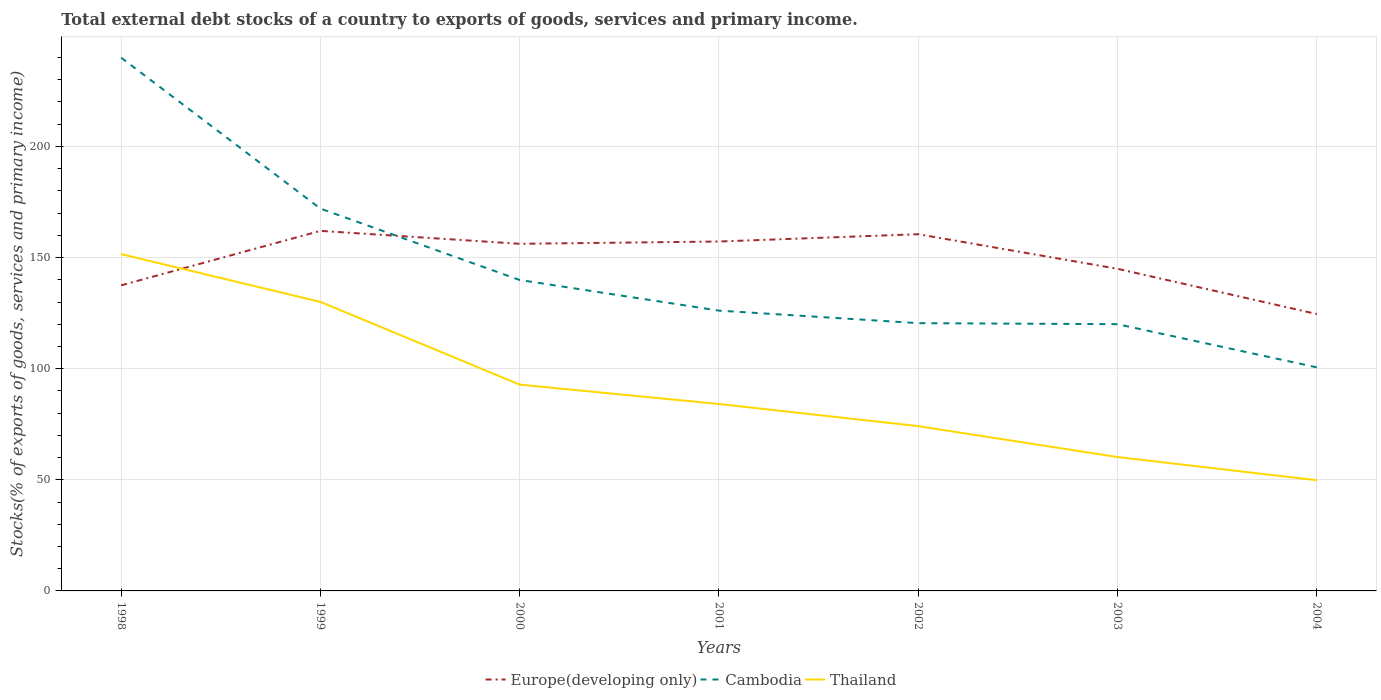How many different coloured lines are there?
Give a very brief answer. 3. Does the line corresponding to Europe(developing only) intersect with the line corresponding to Cambodia?
Offer a very short reply. Yes. Is the number of lines equal to the number of legend labels?
Offer a terse response. Yes. Across all years, what is the maximum total debt stocks in Thailand?
Offer a very short reply. 49.81. In which year was the total debt stocks in Thailand maximum?
Your answer should be compact. 2004. What is the total total debt stocks in Thailand in the graph?
Offer a very short reply. 10.43. What is the difference between the highest and the second highest total debt stocks in Europe(developing only)?
Keep it short and to the point. 37.42. What is the difference between the highest and the lowest total debt stocks in Europe(developing only)?
Your answer should be very brief. 4. Is the total debt stocks in Cambodia strictly greater than the total debt stocks in Europe(developing only) over the years?
Your response must be concise. No. How many lines are there?
Your answer should be compact. 3. How many years are there in the graph?
Your answer should be compact. 7. What is the difference between two consecutive major ticks on the Y-axis?
Provide a short and direct response. 50. Where does the legend appear in the graph?
Your answer should be very brief. Bottom center. What is the title of the graph?
Ensure brevity in your answer.  Total external debt stocks of a country to exports of goods, services and primary income. Does "Lithuania" appear as one of the legend labels in the graph?
Give a very brief answer. No. What is the label or title of the Y-axis?
Give a very brief answer. Stocks(% of exports of goods, services and primary income). What is the Stocks(% of exports of goods, services and primary income) of Europe(developing only) in 1998?
Offer a terse response. 137.51. What is the Stocks(% of exports of goods, services and primary income) in Cambodia in 1998?
Your response must be concise. 239.93. What is the Stocks(% of exports of goods, services and primary income) of Thailand in 1998?
Your answer should be very brief. 151.54. What is the Stocks(% of exports of goods, services and primary income) in Europe(developing only) in 1999?
Provide a succinct answer. 162.01. What is the Stocks(% of exports of goods, services and primary income) of Cambodia in 1999?
Make the answer very short. 172.03. What is the Stocks(% of exports of goods, services and primary income) in Thailand in 1999?
Give a very brief answer. 130.04. What is the Stocks(% of exports of goods, services and primary income) of Europe(developing only) in 2000?
Your response must be concise. 156.19. What is the Stocks(% of exports of goods, services and primary income) in Cambodia in 2000?
Offer a very short reply. 139.91. What is the Stocks(% of exports of goods, services and primary income) in Thailand in 2000?
Ensure brevity in your answer.  92.83. What is the Stocks(% of exports of goods, services and primary income) in Europe(developing only) in 2001?
Ensure brevity in your answer.  157.22. What is the Stocks(% of exports of goods, services and primary income) in Cambodia in 2001?
Ensure brevity in your answer.  126.13. What is the Stocks(% of exports of goods, services and primary income) of Thailand in 2001?
Your answer should be very brief. 84.1. What is the Stocks(% of exports of goods, services and primary income) of Europe(developing only) in 2002?
Offer a very short reply. 160.51. What is the Stocks(% of exports of goods, services and primary income) of Cambodia in 2002?
Your answer should be very brief. 120.48. What is the Stocks(% of exports of goods, services and primary income) of Thailand in 2002?
Provide a succinct answer. 74.14. What is the Stocks(% of exports of goods, services and primary income) of Europe(developing only) in 2003?
Keep it short and to the point. 144.95. What is the Stocks(% of exports of goods, services and primary income) of Cambodia in 2003?
Your answer should be very brief. 120.03. What is the Stocks(% of exports of goods, services and primary income) of Thailand in 2003?
Your answer should be very brief. 60.24. What is the Stocks(% of exports of goods, services and primary income) of Europe(developing only) in 2004?
Make the answer very short. 124.59. What is the Stocks(% of exports of goods, services and primary income) of Cambodia in 2004?
Provide a short and direct response. 100.6. What is the Stocks(% of exports of goods, services and primary income) in Thailand in 2004?
Offer a terse response. 49.81. Across all years, what is the maximum Stocks(% of exports of goods, services and primary income) in Europe(developing only)?
Provide a short and direct response. 162.01. Across all years, what is the maximum Stocks(% of exports of goods, services and primary income) in Cambodia?
Give a very brief answer. 239.93. Across all years, what is the maximum Stocks(% of exports of goods, services and primary income) of Thailand?
Offer a very short reply. 151.54. Across all years, what is the minimum Stocks(% of exports of goods, services and primary income) of Europe(developing only)?
Keep it short and to the point. 124.59. Across all years, what is the minimum Stocks(% of exports of goods, services and primary income) in Cambodia?
Offer a very short reply. 100.6. Across all years, what is the minimum Stocks(% of exports of goods, services and primary income) in Thailand?
Give a very brief answer. 49.81. What is the total Stocks(% of exports of goods, services and primary income) of Europe(developing only) in the graph?
Your answer should be very brief. 1042.97. What is the total Stocks(% of exports of goods, services and primary income) of Cambodia in the graph?
Offer a very short reply. 1019.11. What is the total Stocks(% of exports of goods, services and primary income) in Thailand in the graph?
Ensure brevity in your answer.  642.71. What is the difference between the Stocks(% of exports of goods, services and primary income) in Europe(developing only) in 1998 and that in 1999?
Give a very brief answer. -24.5. What is the difference between the Stocks(% of exports of goods, services and primary income) of Cambodia in 1998 and that in 1999?
Offer a terse response. 67.9. What is the difference between the Stocks(% of exports of goods, services and primary income) in Thailand in 1998 and that in 1999?
Keep it short and to the point. 21.5. What is the difference between the Stocks(% of exports of goods, services and primary income) of Europe(developing only) in 1998 and that in 2000?
Make the answer very short. -18.68. What is the difference between the Stocks(% of exports of goods, services and primary income) of Cambodia in 1998 and that in 2000?
Provide a short and direct response. 100.02. What is the difference between the Stocks(% of exports of goods, services and primary income) of Thailand in 1998 and that in 2000?
Your answer should be compact. 58.71. What is the difference between the Stocks(% of exports of goods, services and primary income) in Europe(developing only) in 1998 and that in 2001?
Your response must be concise. -19.71. What is the difference between the Stocks(% of exports of goods, services and primary income) of Cambodia in 1998 and that in 2001?
Provide a short and direct response. 113.8. What is the difference between the Stocks(% of exports of goods, services and primary income) in Thailand in 1998 and that in 2001?
Give a very brief answer. 67.45. What is the difference between the Stocks(% of exports of goods, services and primary income) in Europe(developing only) in 1998 and that in 2002?
Your answer should be compact. -23. What is the difference between the Stocks(% of exports of goods, services and primary income) in Cambodia in 1998 and that in 2002?
Keep it short and to the point. 119.44. What is the difference between the Stocks(% of exports of goods, services and primary income) in Thailand in 1998 and that in 2002?
Offer a very short reply. 77.4. What is the difference between the Stocks(% of exports of goods, services and primary income) of Europe(developing only) in 1998 and that in 2003?
Keep it short and to the point. -7.44. What is the difference between the Stocks(% of exports of goods, services and primary income) in Cambodia in 1998 and that in 2003?
Make the answer very short. 119.9. What is the difference between the Stocks(% of exports of goods, services and primary income) in Thailand in 1998 and that in 2003?
Your answer should be very brief. 91.3. What is the difference between the Stocks(% of exports of goods, services and primary income) of Europe(developing only) in 1998 and that in 2004?
Ensure brevity in your answer.  12.92. What is the difference between the Stocks(% of exports of goods, services and primary income) in Cambodia in 1998 and that in 2004?
Ensure brevity in your answer.  139.33. What is the difference between the Stocks(% of exports of goods, services and primary income) of Thailand in 1998 and that in 2004?
Give a very brief answer. 101.73. What is the difference between the Stocks(% of exports of goods, services and primary income) of Europe(developing only) in 1999 and that in 2000?
Give a very brief answer. 5.82. What is the difference between the Stocks(% of exports of goods, services and primary income) in Cambodia in 1999 and that in 2000?
Offer a terse response. 32.12. What is the difference between the Stocks(% of exports of goods, services and primary income) in Thailand in 1999 and that in 2000?
Your answer should be very brief. 37.22. What is the difference between the Stocks(% of exports of goods, services and primary income) in Europe(developing only) in 1999 and that in 2001?
Provide a succinct answer. 4.79. What is the difference between the Stocks(% of exports of goods, services and primary income) of Cambodia in 1999 and that in 2001?
Ensure brevity in your answer.  45.9. What is the difference between the Stocks(% of exports of goods, services and primary income) of Thailand in 1999 and that in 2001?
Give a very brief answer. 45.95. What is the difference between the Stocks(% of exports of goods, services and primary income) in Europe(developing only) in 1999 and that in 2002?
Provide a short and direct response. 1.5. What is the difference between the Stocks(% of exports of goods, services and primary income) in Cambodia in 1999 and that in 2002?
Your answer should be very brief. 51.55. What is the difference between the Stocks(% of exports of goods, services and primary income) of Thailand in 1999 and that in 2002?
Make the answer very short. 55.9. What is the difference between the Stocks(% of exports of goods, services and primary income) of Europe(developing only) in 1999 and that in 2003?
Offer a very short reply. 17.06. What is the difference between the Stocks(% of exports of goods, services and primary income) of Cambodia in 1999 and that in 2003?
Ensure brevity in your answer.  52. What is the difference between the Stocks(% of exports of goods, services and primary income) in Thailand in 1999 and that in 2003?
Ensure brevity in your answer.  69.8. What is the difference between the Stocks(% of exports of goods, services and primary income) in Europe(developing only) in 1999 and that in 2004?
Provide a succinct answer. 37.42. What is the difference between the Stocks(% of exports of goods, services and primary income) of Cambodia in 1999 and that in 2004?
Provide a short and direct response. 71.43. What is the difference between the Stocks(% of exports of goods, services and primary income) in Thailand in 1999 and that in 2004?
Make the answer very short. 80.23. What is the difference between the Stocks(% of exports of goods, services and primary income) of Europe(developing only) in 2000 and that in 2001?
Keep it short and to the point. -1.03. What is the difference between the Stocks(% of exports of goods, services and primary income) of Cambodia in 2000 and that in 2001?
Ensure brevity in your answer.  13.78. What is the difference between the Stocks(% of exports of goods, services and primary income) of Thailand in 2000 and that in 2001?
Your answer should be very brief. 8.73. What is the difference between the Stocks(% of exports of goods, services and primary income) in Europe(developing only) in 2000 and that in 2002?
Make the answer very short. -4.32. What is the difference between the Stocks(% of exports of goods, services and primary income) in Cambodia in 2000 and that in 2002?
Offer a very short reply. 19.43. What is the difference between the Stocks(% of exports of goods, services and primary income) in Thailand in 2000 and that in 2002?
Ensure brevity in your answer.  18.68. What is the difference between the Stocks(% of exports of goods, services and primary income) in Europe(developing only) in 2000 and that in 2003?
Ensure brevity in your answer.  11.24. What is the difference between the Stocks(% of exports of goods, services and primary income) of Cambodia in 2000 and that in 2003?
Provide a short and direct response. 19.88. What is the difference between the Stocks(% of exports of goods, services and primary income) of Thailand in 2000 and that in 2003?
Your answer should be very brief. 32.59. What is the difference between the Stocks(% of exports of goods, services and primary income) in Europe(developing only) in 2000 and that in 2004?
Provide a succinct answer. 31.6. What is the difference between the Stocks(% of exports of goods, services and primary income) in Cambodia in 2000 and that in 2004?
Provide a short and direct response. 39.31. What is the difference between the Stocks(% of exports of goods, services and primary income) in Thailand in 2000 and that in 2004?
Your response must be concise. 43.01. What is the difference between the Stocks(% of exports of goods, services and primary income) in Europe(developing only) in 2001 and that in 2002?
Your answer should be compact. -3.29. What is the difference between the Stocks(% of exports of goods, services and primary income) of Cambodia in 2001 and that in 2002?
Your answer should be very brief. 5.64. What is the difference between the Stocks(% of exports of goods, services and primary income) of Thailand in 2001 and that in 2002?
Provide a short and direct response. 9.95. What is the difference between the Stocks(% of exports of goods, services and primary income) in Europe(developing only) in 2001 and that in 2003?
Ensure brevity in your answer.  12.27. What is the difference between the Stocks(% of exports of goods, services and primary income) of Cambodia in 2001 and that in 2003?
Your response must be concise. 6.1. What is the difference between the Stocks(% of exports of goods, services and primary income) in Thailand in 2001 and that in 2003?
Ensure brevity in your answer.  23.85. What is the difference between the Stocks(% of exports of goods, services and primary income) in Europe(developing only) in 2001 and that in 2004?
Offer a very short reply. 32.63. What is the difference between the Stocks(% of exports of goods, services and primary income) in Cambodia in 2001 and that in 2004?
Provide a succinct answer. 25.53. What is the difference between the Stocks(% of exports of goods, services and primary income) of Thailand in 2001 and that in 2004?
Offer a very short reply. 34.28. What is the difference between the Stocks(% of exports of goods, services and primary income) of Europe(developing only) in 2002 and that in 2003?
Your answer should be compact. 15.55. What is the difference between the Stocks(% of exports of goods, services and primary income) of Cambodia in 2002 and that in 2003?
Offer a very short reply. 0.46. What is the difference between the Stocks(% of exports of goods, services and primary income) in Thailand in 2002 and that in 2003?
Your answer should be compact. 13.9. What is the difference between the Stocks(% of exports of goods, services and primary income) of Europe(developing only) in 2002 and that in 2004?
Your answer should be very brief. 35.92. What is the difference between the Stocks(% of exports of goods, services and primary income) in Cambodia in 2002 and that in 2004?
Keep it short and to the point. 19.88. What is the difference between the Stocks(% of exports of goods, services and primary income) in Thailand in 2002 and that in 2004?
Your answer should be compact. 24.33. What is the difference between the Stocks(% of exports of goods, services and primary income) in Europe(developing only) in 2003 and that in 2004?
Give a very brief answer. 20.36. What is the difference between the Stocks(% of exports of goods, services and primary income) in Cambodia in 2003 and that in 2004?
Offer a very short reply. 19.43. What is the difference between the Stocks(% of exports of goods, services and primary income) of Thailand in 2003 and that in 2004?
Keep it short and to the point. 10.43. What is the difference between the Stocks(% of exports of goods, services and primary income) in Europe(developing only) in 1998 and the Stocks(% of exports of goods, services and primary income) in Cambodia in 1999?
Your answer should be compact. -34.52. What is the difference between the Stocks(% of exports of goods, services and primary income) in Europe(developing only) in 1998 and the Stocks(% of exports of goods, services and primary income) in Thailand in 1999?
Make the answer very short. 7.47. What is the difference between the Stocks(% of exports of goods, services and primary income) in Cambodia in 1998 and the Stocks(% of exports of goods, services and primary income) in Thailand in 1999?
Your answer should be compact. 109.88. What is the difference between the Stocks(% of exports of goods, services and primary income) in Europe(developing only) in 1998 and the Stocks(% of exports of goods, services and primary income) in Cambodia in 2000?
Give a very brief answer. -2.4. What is the difference between the Stocks(% of exports of goods, services and primary income) in Europe(developing only) in 1998 and the Stocks(% of exports of goods, services and primary income) in Thailand in 2000?
Keep it short and to the point. 44.68. What is the difference between the Stocks(% of exports of goods, services and primary income) of Cambodia in 1998 and the Stocks(% of exports of goods, services and primary income) of Thailand in 2000?
Provide a short and direct response. 147.1. What is the difference between the Stocks(% of exports of goods, services and primary income) in Europe(developing only) in 1998 and the Stocks(% of exports of goods, services and primary income) in Cambodia in 2001?
Your response must be concise. 11.38. What is the difference between the Stocks(% of exports of goods, services and primary income) of Europe(developing only) in 1998 and the Stocks(% of exports of goods, services and primary income) of Thailand in 2001?
Your answer should be compact. 53.41. What is the difference between the Stocks(% of exports of goods, services and primary income) in Cambodia in 1998 and the Stocks(% of exports of goods, services and primary income) in Thailand in 2001?
Your answer should be very brief. 155.83. What is the difference between the Stocks(% of exports of goods, services and primary income) in Europe(developing only) in 1998 and the Stocks(% of exports of goods, services and primary income) in Cambodia in 2002?
Your answer should be compact. 17.02. What is the difference between the Stocks(% of exports of goods, services and primary income) in Europe(developing only) in 1998 and the Stocks(% of exports of goods, services and primary income) in Thailand in 2002?
Provide a succinct answer. 63.36. What is the difference between the Stocks(% of exports of goods, services and primary income) of Cambodia in 1998 and the Stocks(% of exports of goods, services and primary income) of Thailand in 2002?
Your answer should be very brief. 165.78. What is the difference between the Stocks(% of exports of goods, services and primary income) of Europe(developing only) in 1998 and the Stocks(% of exports of goods, services and primary income) of Cambodia in 2003?
Give a very brief answer. 17.48. What is the difference between the Stocks(% of exports of goods, services and primary income) of Europe(developing only) in 1998 and the Stocks(% of exports of goods, services and primary income) of Thailand in 2003?
Keep it short and to the point. 77.27. What is the difference between the Stocks(% of exports of goods, services and primary income) in Cambodia in 1998 and the Stocks(% of exports of goods, services and primary income) in Thailand in 2003?
Ensure brevity in your answer.  179.69. What is the difference between the Stocks(% of exports of goods, services and primary income) of Europe(developing only) in 1998 and the Stocks(% of exports of goods, services and primary income) of Cambodia in 2004?
Your answer should be compact. 36.91. What is the difference between the Stocks(% of exports of goods, services and primary income) of Europe(developing only) in 1998 and the Stocks(% of exports of goods, services and primary income) of Thailand in 2004?
Make the answer very short. 87.7. What is the difference between the Stocks(% of exports of goods, services and primary income) of Cambodia in 1998 and the Stocks(% of exports of goods, services and primary income) of Thailand in 2004?
Your answer should be very brief. 190.11. What is the difference between the Stocks(% of exports of goods, services and primary income) in Europe(developing only) in 1999 and the Stocks(% of exports of goods, services and primary income) in Cambodia in 2000?
Provide a succinct answer. 22.1. What is the difference between the Stocks(% of exports of goods, services and primary income) of Europe(developing only) in 1999 and the Stocks(% of exports of goods, services and primary income) of Thailand in 2000?
Your answer should be compact. 69.18. What is the difference between the Stocks(% of exports of goods, services and primary income) of Cambodia in 1999 and the Stocks(% of exports of goods, services and primary income) of Thailand in 2000?
Your response must be concise. 79.2. What is the difference between the Stocks(% of exports of goods, services and primary income) in Europe(developing only) in 1999 and the Stocks(% of exports of goods, services and primary income) in Cambodia in 2001?
Ensure brevity in your answer.  35.88. What is the difference between the Stocks(% of exports of goods, services and primary income) of Europe(developing only) in 1999 and the Stocks(% of exports of goods, services and primary income) of Thailand in 2001?
Your answer should be compact. 77.91. What is the difference between the Stocks(% of exports of goods, services and primary income) in Cambodia in 1999 and the Stocks(% of exports of goods, services and primary income) in Thailand in 2001?
Give a very brief answer. 87.93. What is the difference between the Stocks(% of exports of goods, services and primary income) of Europe(developing only) in 1999 and the Stocks(% of exports of goods, services and primary income) of Cambodia in 2002?
Offer a terse response. 41.52. What is the difference between the Stocks(% of exports of goods, services and primary income) of Europe(developing only) in 1999 and the Stocks(% of exports of goods, services and primary income) of Thailand in 2002?
Provide a succinct answer. 87.86. What is the difference between the Stocks(% of exports of goods, services and primary income) of Cambodia in 1999 and the Stocks(% of exports of goods, services and primary income) of Thailand in 2002?
Keep it short and to the point. 97.89. What is the difference between the Stocks(% of exports of goods, services and primary income) of Europe(developing only) in 1999 and the Stocks(% of exports of goods, services and primary income) of Cambodia in 2003?
Keep it short and to the point. 41.98. What is the difference between the Stocks(% of exports of goods, services and primary income) of Europe(developing only) in 1999 and the Stocks(% of exports of goods, services and primary income) of Thailand in 2003?
Provide a succinct answer. 101.77. What is the difference between the Stocks(% of exports of goods, services and primary income) of Cambodia in 1999 and the Stocks(% of exports of goods, services and primary income) of Thailand in 2003?
Make the answer very short. 111.79. What is the difference between the Stocks(% of exports of goods, services and primary income) in Europe(developing only) in 1999 and the Stocks(% of exports of goods, services and primary income) in Cambodia in 2004?
Give a very brief answer. 61.41. What is the difference between the Stocks(% of exports of goods, services and primary income) in Europe(developing only) in 1999 and the Stocks(% of exports of goods, services and primary income) in Thailand in 2004?
Your response must be concise. 112.19. What is the difference between the Stocks(% of exports of goods, services and primary income) in Cambodia in 1999 and the Stocks(% of exports of goods, services and primary income) in Thailand in 2004?
Your answer should be compact. 122.22. What is the difference between the Stocks(% of exports of goods, services and primary income) in Europe(developing only) in 2000 and the Stocks(% of exports of goods, services and primary income) in Cambodia in 2001?
Offer a terse response. 30.06. What is the difference between the Stocks(% of exports of goods, services and primary income) of Europe(developing only) in 2000 and the Stocks(% of exports of goods, services and primary income) of Thailand in 2001?
Provide a short and direct response. 72.09. What is the difference between the Stocks(% of exports of goods, services and primary income) of Cambodia in 2000 and the Stocks(% of exports of goods, services and primary income) of Thailand in 2001?
Provide a short and direct response. 55.81. What is the difference between the Stocks(% of exports of goods, services and primary income) of Europe(developing only) in 2000 and the Stocks(% of exports of goods, services and primary income) of Cambodia in 2002?
Offer a very short reply. 35.71. What is the difference between the Stocks(% of exports of goods, services and primary income) of Europe(developing only) in 2000 and the Stocks(% of exports of goods, services and primary income) of Thailand in 2002?
Provide a short and direct response. 82.05. What is the difference between the Stocks(% of exports of goods, services and primary income) in Cambodia in 2000 and the Stocks(% of exports of goods, services and primary income) in Thailand in 2002?
Offer a terse response. 65.77. What is the difference between the Stocks(% of exports of goods, services and primary income) of Europe(developing only) in 2000 and the Stocks(% of exports of goods, services and primary income) of Cambodia in 2003?
Ensure brevity in your answer.  36.16. What is the difference between the Stocks(% of exports of goods, services and primary income) in Europe(developing only) in 2000 and the Stocks(% of exports of goods, services and primary income) in Thailand in 2003?
Your response must be concise. 95.95. What is the difference between the Stocks(% of exports of goods, services and primary income) in Cambodia in 2000 and the Stocks(% of exports of goods, services and primary income) in Thailand in 2003?
Your answer should be very brief. 79.67. What is the difference between the Stocks(% of exports of goods, services and primary income) in Europe(developing only) in 2000 and the Stocks(% of exports of goods, services and primary income) in Cambodia in 2004?
Give a very brief answer. 55.59. What is the difference between the Stocks(% of exports of goods, services and primary income) in Europe(developing only) in 2000 and the Stocks(% of exports of goods, services and primary income) in Thailand in 2004?
Give a very brief answer. 106.38. What is the difference between the Stocks(% of exports of goods, services and primary income) in Cambodia in 2000 and the Stocks(% of exports of goods, services and primary income) in Thailand in 2004?
Make the answer very short. 90.1. What is the difference between the Stocks(% of exports of goods, services and primary income) in Europe(developing only) in 2001 and the Stocks(% of exports of goods, services and primary income) in Cambodia in 2002?
Give a very brief answer. 36.73. What is the difference between the Stocks(% of exports of goods, services and primary income) of Europe(developing only) in 2001 and the Stocks(% of exports of goods, services and primary income) of Thailand in 2002?
Ensure brevity in your answer.  83.07. What is the difference between the Stocks(% of exports of goods, services and primary income) in Cambodia in 2001 and the Stocks(% of exports of goods, services and primary income) in Thailand in 2002?
Provide a succinct answer. 51.98. What is the difference between the Stocks(% of exports of goods, services and primary income) in Europe(developing only) in 2001 and the Stocks(% of exports of goods, services and primary income) in Cambodia in 2003?
Provide a short and direct response. 37.19. What is the difference between the Stocks(% of exports of goods, services and primary income) in Europe(developing only) in 2001 and the Stocks(% of exports of goods, services and primary income) in Thailand in 2003?
Your answer should be very brief. 96.98. What is the difference between the Stocks(% of exports of goods, services and primary income) in Cambodia in 2001 and the Stocks(% of exports of goods, services and primary income) in Thailand in 2003?
Make the answer very short. 65.89. What is the difference between the Stocks(% of exports of goods, services and primary income) of Europe(developing only) in 2001 and the Stocks(% of exports of goods, services and primary income) of Cambodia in 2004?
Give a very brief answer. 56.62. What is the difference between the Stocks(% of exports of goods, services and primary income) of Europe(developing only) in 2001 and the Stocks(% of exports of goods, services and primary income) of Thailand in 2004?
Offer a terse response. 107.4. What is the difference between the Stocks(% of exports of goods, services and primary income) of Cambodia in 2001 and the Stocks(% of exports of goods, services and primary income) of Thailand in 2004?
Keep it short and to the point. 76.31. What is the difference between the Stocks(% of exports of goods, services and primary income) of Europe(developing only) in 2002 and the Stocks(% of exports of goods, services and primary income) of Cambodia in 2003?
Your answer should be compact. 40.48. What is the difference between the Stocks(% of exports of goods, services and primary income) in Europe(developing only) in 2002 and the Stocks(% of exports of goods, services and primary income) in Thailand in 2003?
Keep it short and to the point. 100.26. What is the difference between the Stocks(% of exports of goods, services and primary income) of Cambodia in 2002 and the Stocks(% of exports of goods, services and primary income) of Thailand in 2003?
Your answer should be compact. 60.24. What is the difference between the Stocks(% of exports of goods, services and primary income) of Europe(developing only) in 2002 and the Stocks(% of exports of goods, services and primary income) of Cambodia in 2004?
Offer a very short reply. 59.91. What is the difference between the Stocks(% of exports of goods, services and primary income) in Europe(developing only) in 2002 and the Stocks(% of exports of goods, services and primary income) in Thailand in 2004?
Provide a succinct answer. 110.69. What is the difference between the Stocks(% of exports of goods, services and primary income) in Cambodia in 2002 and the Stocks(% of exports of goods, services and primary income) in Thailand in 2004?
Your answer should be compact. 70.67. What is the difference between the Stocks(% of exports of goods, services and primary income) in Europe(developing only) in 2003 and the Stocks(% of exports of goods, services and primary income) in Cambodia in 2004?
Your answer should be compact. 44.35. What is the difference between the Stocks(% of exports of goods, services and primary income) in Europe(developing only) in 2003 and the Stocks(% of exports of goods, services and primary income) in Thailand in 2004?
Your answer should be very brief. 95.14. What is the difference between the Stocks(% of exports of goods, services and primary income) of Cambodia in 2003 and the Stocks(% of exports of goods, services and primary income) of Thailand in 2004?
Make the answer very short. 70.21. What is the average Stocks(% of exports of goods, services and primary income) of Europe(developing only) per year?
Your response must be concise. 149. What is the average Stocks(% of exports of goods, services and primary income) in Cambodia per year?
Provide a short and direct response. 145.59. What is the average Stocks(% of exports of goods, services and primary income) of Thailand per year?
Provide a succinct answer. 91.82. In the year 1998, what is the difference between the Stocks(% of exports of goods, services and primary income) in Europe(developing only) and Stocks(% of exports of goods, services and primary income) in Cambodia?
Give a very brief answer. -102.42. In the year 1998, what is the difference between the Stocks(% of exports of goods, services and primary income) of Europe(developing only) and Stocks(% of exports of goods, services and primary income) of Thailand?
Your response must be concise. -14.03. In the year 1998, what is the difference between the Stocks(% of exports of goods, services and primary income) of Cambodia and Stocks(% of exports of goods, services and primary income) of Thailand?
Your answer should be very brief. 88.38. In the year 1999, what is the difference between the Stocks(% of exports of goods, services and primary income) of Europe(developing only) and Stocks(% of exports of goods, services and primary income) of Cambodia?
Give a very brief answer. -10.02. In the year 1999, what is the difference between the Stocks(% of exports of goods, services and primary income) of Europe(developing only) and Stocks(% of exports of goods, services and primary income) of Thailand?
Keep it short and to the point. 31.96. In the year 1999, what is the difference between the Stocks(% of exports of goods, services and primary income) of Cambodia and Stocks(% of exports of goods, services and primary income) of Thailand?
Keep it short and to the point. 41.99. In the year 2000, what is the difference between the Stocks(% of exports of goods, services and primary income) in Europe(developing only) and Stocks(% of exports of goods, services and primary income) in Cambodia?
Offer a terse response. 16.28. In the year 2000, what is the difference between the Stocks(% of exports of goods, services and primary income) of Europe(developing only) and Stocks(% of exports of goods, services and primary income) of Thailand?
Make the answer very short. 63.36. In the year 2000, what is the difference between the Stocks(% of exports of goods, services and primary income) of Cambodia and Stocks(% of exports of goods, services and primary income) of Thailand?
Make the answer very short. 47.08. In the year 2001, what is the difference between the Stocks(% of exports of goods, services and primary income) of Europe(developing only) and Stocks(% of exports of goods, services and primary income) of Cambodia?
Offer a very short reply. 31.09. In the year 2001, what is the difference between the Stocks(% of exports of goods, services and primary income) in Europe(developing only) and Stocks(% of exports of goods, services and primary income) in Thailand?
Your answer should be compact. 73.12. In the year 2001, what is the difference between the Stocks(% of exports of goods, services and primary income) of Cambodia and Stocks(% of exports of goods, services and primary income) of Thailand?
Ensure brevity in your answer.  42.03. In the year 2002, what is the difference between the Stocks(% of exports of goods, services and primary income) in Europe(developing only) and Stocks(% of exports of goods, services and primary income) in Cambodia?
Offer a terse response. 40.02. In the year 2002, what is the difference between the Stocks(% of exports of goods, services and primary income) in Europe(developing only) and Stocks(% of exports of goods, services and primary income) in Thailand?
Make the answer very short. 86.36. In the year 2002, what is the difference between the Stocks(% of exports of goods, services and primary income) in Cambodia and Stocks(% of exports of goods, services and primary income) in Thailand?
Make the answer very short. 46.34. In the year 2003, what is the difference between the Stocks(% of exports of goods, services and primary income) in Europe(developing only) and Stocks(% of exports of goods, services and primary income) in Cambodia?
Offer a very short reply. 24.92. In the year 2003, what is the difference between the Stocks(% of exports of goods, services and primary income) of Europe(developing only) and Stocks(% of exports of goods, services and primary income) of Thailand?
Offer a very short reply. 84.71. In the year 2003, what is the difference between the Stocks(% of exports of goods, services and primary income) of Cambodia and Stocks(% of exports of goods, services and primary income) of Thailand?
Your response must be concise. 59.79. In the year 2004, what is the difference between the Stocks(% of exports of goods, services and primary income) of Europe(developing only) and Stocks(% of exports of goods, services and primary income) of Cambodia?
Provide a short and direct response. 23.99. In the year 2004, what is the difference between the Stocks(% of exports of goods, services and primary income) of Europe(developing only) and Stocks(% of exports of goods, services and primary income) of Thailand?
Offer a terse response. 74.77. In the year 2004, what is the difference between the Stocks(% of exports of goods, services and primary income) of Cambodia and Stocks(% of exports of goods, services and primary income) of Thailand?
Provide a succinct answer. 50.79. What is the ratio of the Stocks(% of exports of goods, services and primary income) in Europe(developing only) in 1998 to that in 1999?
Make the answer very short. 0.85. What is the ratio of the Stocks(% of exports of goods, services and primary income) in Cambodia in 1998 to that in 1999?
Your answer should be very brief. 1.39. What is the ratio of the Stocks(% of exports of goods, services and primary income) of Thailand in 1998 to that in 1999?
Keep it short and to the point. 1.17. What is the ratio of the Stocks(% of exports of goods, services and primary income) of Europe(developing only) in 1998 to that in 2000?
Offer a very short reply. 0.88. What is the ratio of the Stocks(% of exports of goods, services and primary income) of Cambodia in 1998 to that in 2000?
Give a very brief answer. 1.71. What is the ratio of the Stocks(% of exports of goods, services and primary income) in Thailand in 1998 to that in 2000?
Your response must be concise. 1.63. What is the ratio of the Stocks(% of exports of goods, services and primary income) in Europe(developing only) in 1998 to that in 2001?
Make the answer very short. 0.87. What is the ratio of the Stocks(% of exports of goods, services and primary income) in Cambodia in 1998 to that in 2001?
Give a very brief answer. 1.9. What is the ratio of the Stocks(% of exports of goods, services and primary income) in Thailand in 1998 to that in 2001?
Provide a succinct answer. 1.8. What is the ratio of the Stocks(% of exports of goods, services and primary income) in Europe(developing only) in 1998 to that in 2002?
Provide a succinct answer. 0.86. What is the ratio of the Stocks(% of exports of goods, services and primary income) of Cambodia in 1998 to that in 2002?
Provide a succinct answer. 1.99. What is the ratio of the Stocks(% of exports of goods, services and primary income) in Thailand in 1998 to that in 2002?
Ensure brevity in your answer.  2.04. What is the ratio of the Stocks(% of exports of goods, services and primary income) of Europe(developing only) in 1998 to that in 2003?
Make the answer very short. 0.95. What is the ratio of the Stocks(% of exports of goods, services and primary income) of Cambodia in 1998 to that in 2003?
Provide a succinct answer. 2. What is the ratio of the Stocks(% of exports of goods, services and primary income) in Thailand in 1998 to that in 2003?
Provide a short and direct response. 2.52. What is the ratio of the Stocks(% of exports of goods, services and primary income) of Europe(developing only) in 1998 to that in 2004?
Your answer should be very brief. 1.1. What is the ratio of the Stocks(% of exports of goods, services and primary income) of Cambodia in 1998 to that in 2004?
Offer a very short reply. 2.38. What is the ratio of the Stocks(% of exports of goods, services and primary income) of Thailand in 1998 to that in 2004?
Keep it short and to the point. 3.04. What is the ratio of the Stocks(% of exports of goods, services and primary income) in Europe(developing only) in 1999 to that in 2000?
Give a very brief answer. 1.04. What is the ratio of the Stocks(% of exports of goods, services and primary income) in Cambodia in 1999 to that in 2000?
Give a very brief answer. 1.23. What is the ratio of the Stocks(% of exports of goods, services and primary income) of Thailand in 1999 to that in 2000?
Your response must be concise. 1.4. What is the ratio of the Stocks(% of exports of goods, services and primary income) in Europe(developing only) in 1999 to that in 2001?
Ensure brevity in your answer.  1.03. What is the ratio of the Stocks(% of exports of goods, services and primary income) in Cambodia in 1999 to that in 2001?
Your response must be concise. 1.36. What is the ratio of the Stocks(% of exports of goods, services and primary income) of Thailand in 1999 to that in 2001?
Your answer should be very brief. 1.55. What is the ratio of the Stocks(% of exports of goods, services and primary income) of Europe(developing only) in 1999 to that in 2002?
Give a very brief answer. 1.01. What is the ratio of the Stocks(% of exports of goods, services and primary income) of Cambodia in 1999 to that in 2002?
Make the answer very short. 1.43. What is the ratio of the Stocks(% of exports of goods, services and primary income) in Thailand in 1999 to that in 2002?
Provide a succinct answer. 1.75. What is the ratio of the Stocks(% of exports of goods, services and primary income) in Europe(developing only) in 1999 to that in 2003?
Provide a succinct answer. 1.12. What is the ratio of the Stocks(% of exports of goods, services and primary income) of Cambodia in 1999 to that in 2003?
Ensure brevity in your answer.  1.43. What is the ratio of the Stocks(% of exports of goods, services and primary income) in Thailand in 1999 to that in 2003?
Your answer should be very brief. 2.16. What is the ratio of the Stocks(% of exports of goods, services and primary income) of Europe(developing only) in 1999 to that in 2004?
Your answer should be compact. 1.3. What is the ratio of the Stocks(% of exports of goods, services and primary income) of Cambodia in 1999 to that in 2004?
Your response must be concise. 1.71. What is the ratio of the Stocks(% of exports of goods, services and primary income) in Thailand in 1999 to that in 2004?
Your response must be concise. 2.61. What is the ratio of the Stocks(% of exports of goods, services and primary income) in Cambodia in 2000 to that in 2001?
Ensure brevity in your answer.  1.11. What is the ratio of the Stocks(% of exports of goods, services and primary income) of Thailand in 2000 to that in 2001?
Your answer should be compact. 1.1. What is the ratio of the Stocks(% of exports of goods, services and primary income) in Europe(developing only) in 2000 to that in 2002?
Your answer should be compact. 0.97. What is the ratio of the Stocks(% of exports of goods, services and primary income) in Cambodia in 2000 to that in 2002?
Offer a terse response. 1.16. What is the ratio of the Stocks(% of exports of goods, services and primary income) in Thailand in 2000 to that in 2002?
Provide a short and direct response. 1.25. What is the ratio of the Stocks(% of exports of goods, services and primary income) of Europe(developing only) in 2000 to that in 2003?
Make the answer very short. 1.08. What is the ratio of the Stocks(% of exports of goods, services and primary income) in Cambodia in 2000 to that in 2003?
Your response must be concise. 1.17. What is the ratio of the Stocks(% of exports of goods, services and primary income) in Thailand in 2000 to that in 2003?
Offer a very short reply. 1.54. What is the ratio of the Stocks(% of exports of goods, services and primary income) in Europe(developing only) in 2000 to that in 2004?
Your response must be concise. 1.25. What is the ratio of the Stocks(% of exports of goods, services and primary income) of Cambodia in 2000 to that in 2004?
Make the answer very short. 1.39. What is the ratio of the Stocks(% of exports of goods, services and primary income) in Thailand in 2000 to that in 2004?
Your answer should be very brief. 1.86. What is the ratio of the Stocks(% of exports of goods, services and primary income) of Europe(developing only) in 2001 to that in 2002?
Your response must be concise. 0.98. What is the ratio of the Stocks(% of exports of goods, services and primary income) of Cambodia in 2001 to that in 2002?
Your response must be concise. 1.05. What is the ratio of the Stocks(% of exports of goods, services and primary income) in Thailand in 2001 to that in 2002?
Give a very brief answer. 1.13. What is the ratio of the Stocks(% of exports of goods, services and primary income) of Europe(developing only) in 2001 to that in 2003?
Give a very brief answer. 1.08. What is the ratio of the Stocks(% of exports of goods, services and primary income) of Cambodia in 2001 to that in 2003?
Keep it short and to the point. 1.05. What is the ratio of the Stocks(% of exports of goods, services and primary income) in Thailand in 2001 to that in 2003?
Provide a succinct answer. 1.4. What is the ratio of the Stocks(% of exports of goods, services and primary income) in Europe(developing only) in 2001 to that in 2004?
Your response must be concise. 1.26. What is the ratio of the Stocks(% of exports of goods, services and primary income) of Cambodia in 2001 to that in 2004?
Offer a very short reply. 1.25. What is the ratio of the Stocks(% of exports of goods, services and primary income) in Thailand in 2001 to that in 2004?
Provide a short and direct response. 1.69. What is the ratio of the Stocks(% of exports of goods, services and primary income) in Europe(developing only) in 2002 to that in 2003?
Keep it short and to the point. 1.11. What is the ratio of the Stocks(% of exports of goods, services and primary income) of Thailand in 2002 to that in 2003?
Keep it short and to the point. 1.23. What is the ratio of the Stocks(% of exports of goods, services and primary income) in Europe(developing only) in 2002 to that in 2004?
Keep it short and to the point. 1.29. What is the ratio of the Stocks(% of exports of goods, services and primary income) in Cambodia in 2002 to that in 2004?
Give a very brief answer. 1.2. What is the ratio of the Stocks(% of exports of goods, services and primary income) of Thailand in 2002 to that in 2004?
Make the answer very short. 1.49. What is the ratio of the Stocks(% of exports of goods, services and primary income) of Europe(developing only) in 2003 to that in 2004?
Offer a very short reply. 1.16. What is the ratio of the Stocks(% of exports of goods, services and primary income) in Cambodia in 2003 to that in 2004?
Keep it short and to the point. 1.19. What is the ratio of the Stocks(% of exports of goods, services and primary income) in Thailand in 2003 to that in 2004?
Give a very brief answer. 1.21. What is the difference between the highest and the second highest Stocks(% of exports of goods, services and primary income) in Europe(developing only)?
Make the answer very short. 1.5. What is the difference between the highest and the second highest Stocks(% of exports of goods, services and primary income) of Cambodia?
Make the answer very short. 67.9. What is the difference between the highest and the second highest Stocks(% of exports of goods, services and primary income) of Thailand?
Offer a terse response. 21.5. What is the difference between the highest and the lowest Stocks(% of exports of goods, services and primary income) of Europe(developing only)?
Offer a very short reply. 37.42. What is the difference between the highest and the lowest Stocks(% of exports of goods, services and primary income) in Cambodia?
Provide a short and direct response. 139.33. What is the difference between the highest and the lowest Stocks(% of exports of goods, services and primary income) in Thailand?
Your answer should be compact. 101.73. 